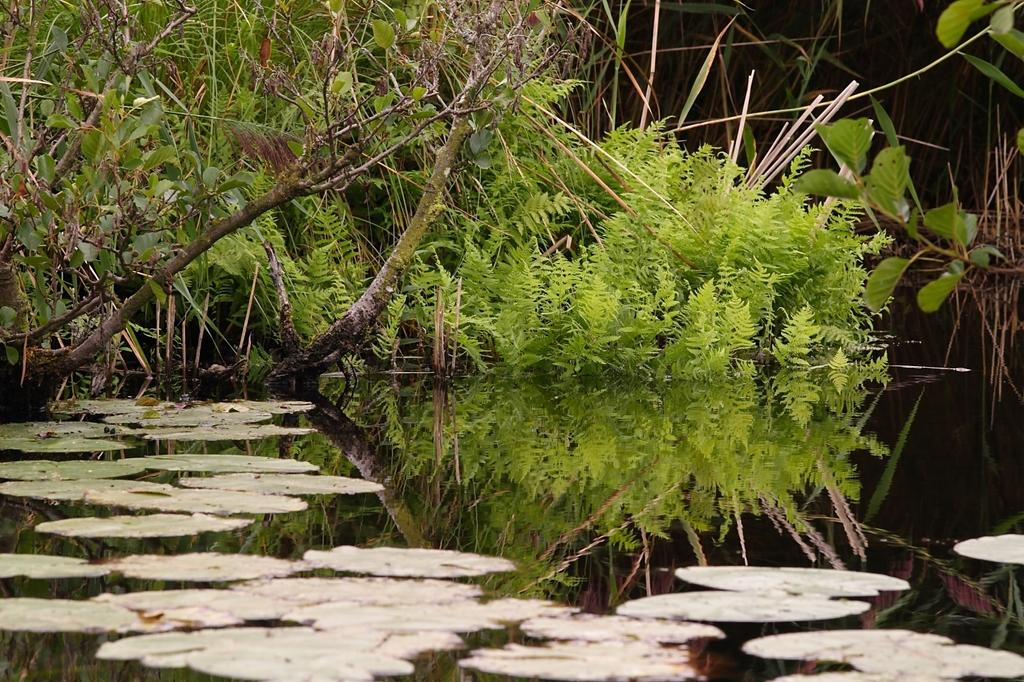What is floating on the water in the image? There are leaves on the water in the image. What can be seen in the background of the image? There are plants visible in the background of the image. What color is the crayon used to draw the leaves in the image? There is no crayon present in the image; the leaves are real and floating on the water. Is the image depicting a winter scene? The image does not provide any information about the season, so it cannot be determined if it is a winter scene. 